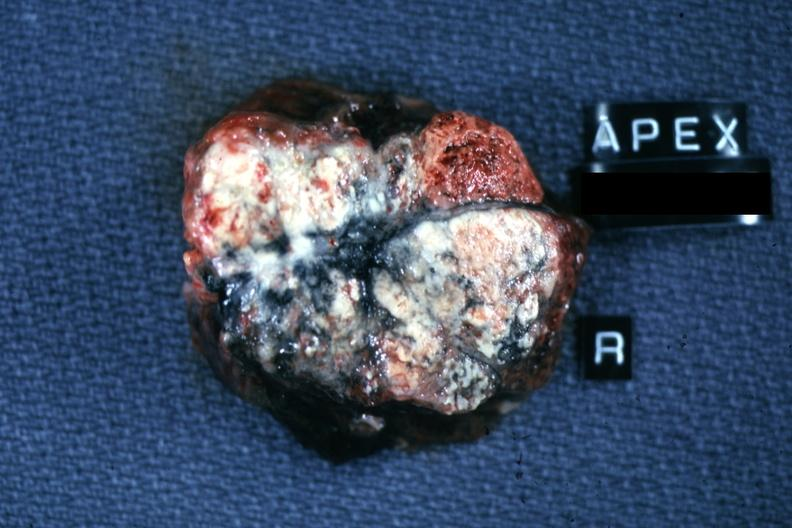what is present?
Answer the question using a single word or phrase. Lymph node 